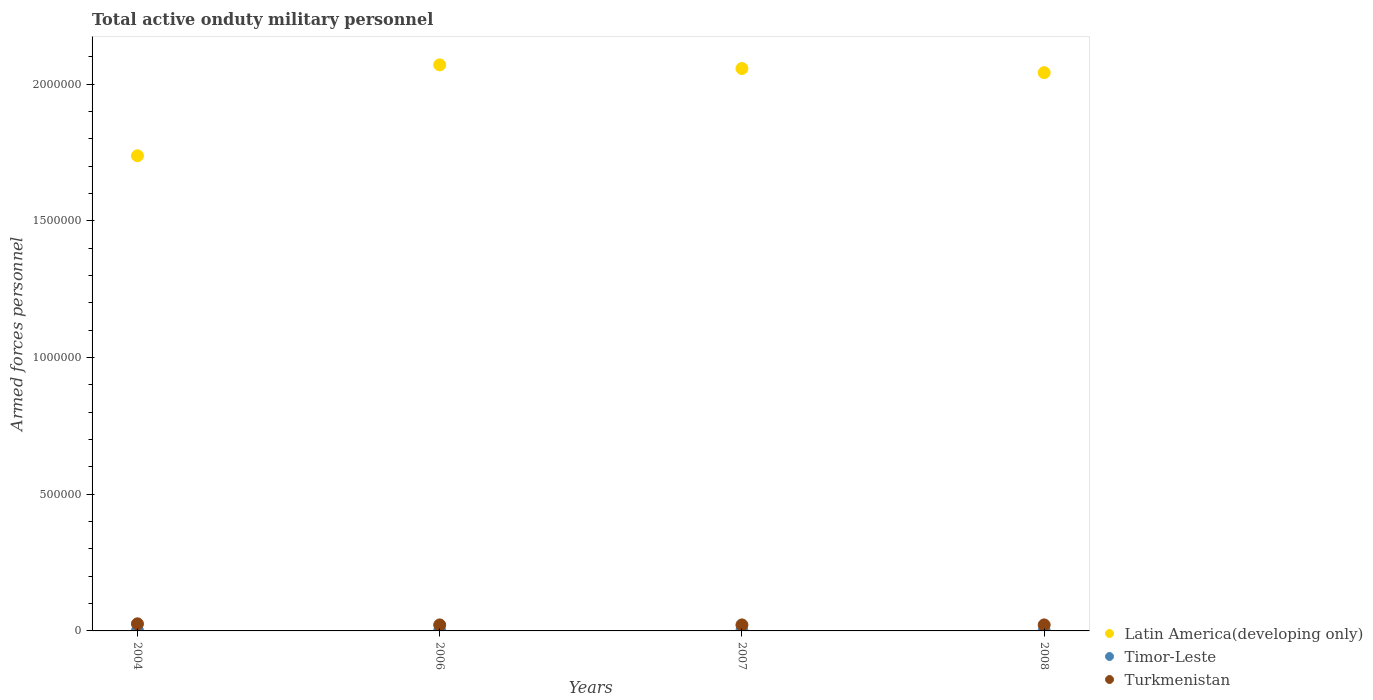What is the number of armed forces personnel in Latin America(developing only) in 2004?
Keep it short and to the point. 1.74e+06. Across all years, what is the minimum number of armed forces personnel in Turkmenistan?
Give a very brief answer. 2.20e+04. In which year was the number of armed forces personnel in Timor-Leste minimum?
Offer a terse response. 2004. What is the total number of armed forces personnel in Turkmenistan in the graph?
Make the answer very short. 9.20e+04. What is the difference between the number of armed forces personnel in Timor-Leste in 2006 and that in 2008?
Provide a succinct answer. 0. What is the difference between the number of armed forces personnel in Turkmenistan in 2006 and the number of armed forces personnel in Timor-Leste in 2007?
Your answer should be very brief. 2.10e+04. What is the average number of armed forces personnel in Turkmenistan per year?
Make the answer very short. 2.30e+04. In the year 2006, what is the difference between the number of armed forces personnel in Timor-Leste and number of armed forces personnel in Latin America(developing only)?
Offer a very short reply. -2.07e+06. In how many years, is the number of armed forces personnel in Latin America(developing only) greater than 800000?
Your answer should be very brief. 4. What is the ratio of the number of armed forces personnel in Latin America(developing only) in 2004 to that in 2007?
Provide a short and direct response. 0.84. Is the number of armed forces personnel in Timor-Leste in 2004 less than that in 2006?
Keep it short and to the point. No. Is the difference between the number of armed forces personnel in Timor-Leste in 2007 and 2008 greater than the difference between the number of armed forces personnel in Latin America(developing only) in 2007 and 2008?
Give a very brief answer. No. What is the difference between the highest and the second highest number of armed forces personnel in Timor-Leste?
Ensure brevity in your answer.  0. What is the difference between the highest and the lowest number of armed forces personnel in Latin America(developing only)?
Your response must be concise. 3.33e+05. Is the sum of the number of armed forces personnel in Turkmenistan in 2004 and 2006 greater than the maximum number of armed forces personnel in Timor-Leste across all years?
Offer a terse response. Yes. Does the number of armed forces personnel in Turkmenistan monotonically increase over the years?
Offer a very short reply. No. Is the number of armed forces personnel in Latin America(developing only) strictly greater than the number of armed forces personnel in Turkmenistan over the years?
Make the answer very short. Yes. Is the number of armed forces personnel in Turkmenistan strictly less than the number of armed forces personnel in Latin America(developing only) over the years?
Ensure brevity in your answer.  Yes. How many dotlines are there?
Your response must be concise. 3. How many years are there in the graph?
Keep it short and to the point. 4. Are the values on the major ticks of Y-axis written in scientific E-notation?
Your answer should be very brief. No. Does the graph contain any zero values?
Make the answer very short. No. Does the graph contain grids?
Your response must be concise. No. How are the legend labels stacked?
Provide a short and direct response. Vertical. What is the title of the graph?
Make the answer very short. Total active onduty military personnel. What is the label or title of the X-axis?
Keep it short and to the point. Years. What is the label or title of the Y-axis?
Your answer should be very brief. Armed forces personnel. What is the Armed forces personnel of Latin America(developing only) in 2004?
Provide a short and direct response. 1.74e+06. What is the Armed forces personnel of Turkmenistan in 2004?
Give a very brief answer. 2.60e+04. What is the Armed forces personnel in Latin America(developing only) in 2006?
Make the answer very short. 2.07e+06. What is the Armed forces personnel of Timor-Leste in 2006?
Make the answer very short. 1000. What is the Armed forces personnel in Turkmenistan in 2006?
Offer a terse response. 2.20e+04. What is the Armed forces personnel in Latin America(developing only) in 2007?
Provide a short and direct response. 2.06e+06. What is the Armed forces personnel of Turkmenistan in 2007?
Give a very brief answer. 2.20e+04. What is the Armed forces personnel in Latin America(developing only) in 2008?
Ensure brevity in your answer.  2.04e+06. What is the Armed forces personnel in Timor-Leste in 2008?
Provide a short and direct response. 1000. What is the Armed forces personnel in Turkmenistan in 2008?
Ensure brevity in your answer.  2.20e+04. Across all years, what is the maximum Armed forces personnel in Latin America(developing only)?
Your answer should be compact. 2.07e+06. Across all years, what is the maximum Armed forces personnel in Turkmenistan?
Your response must be concise. 2.60e+04. Across all years, what is the minimum Armed forces personnel in Latin America(developing only)?
Your answer should be compact. 1.74e+06. Across all years, what is the minimum Armed forces personnel in Timor-Leste?
Ensure brevity in your answer.  1000. Across all years, what is the minimum Armed forces personnel of Turkmenistan?
Keep it short and to the point. 2.20e+04. What is the total Armed forces personnel in Latin America(developing only) in the graph?
Provide a succinct answer. 7.91e+06. What is the total Armed forces personnel of Timor-Leste in the graph?
Keep it short and to the point. 4000. What is the total Armed forces personnel of Turkmenistan in the graph?
Keep it short and to the point. 9.20e+04. What is the difference between the Armed forces personnel of Latin America(developing only) in 2004 and that in 2006?
Offer a very short reply. -3.33e+05. What is the difference between the Armed forces personnel of Turkmenistan in 2004 and that in 2006?
Provide a short and direct response. 4000. What is the difference between the Armed forces personnel of Latin America(developing only) in 2004 and that in 2007?
Give a very brief answer. -3.19e+05. What is the difference between the Armed forces personnel of Turkmenistan in 2004 and that in 2007?
Your answer should be compact. 4000. What is the difference between the Armed forces personnel of Latin America(developing only) in 2004 and that in 2008?
Your answer should be compact. -3.04e+05. What is the difference between the Armed forces personnel of Timor-Leste in 2004 and that in 2008?
Ensure brevity in your answer.  0. What is the difference between the Armed forces personnel in Turkmenistan in 2004 and that in 2008?
Provide a succinct answer. 4000. What is the difference between the Armed forces personnel in Latin America(developing only) in 2006 and that in 2007?
Your response must be concise. 1.34e+04. What is the difference between the Armed forces personnel of Timor-Leste in 2006 and that in 2007?
Your answer should be compact. 0. What is the difference between the Armed forces personnel of Latin America(developing only) in 2006 and that in 2008?
Provide a succinct answer. 2.84e+04. What is the difference between the Armed forces personnel of Timor-Leste in 2006 and that in 2008?
Your answer should be compact. 0. What is the difference between the Armed forces personnel in Latin America(developing only) in 2007 and that in 2008?
Make the answer very short. 1.50e+04. What is the difference between the Armed forces personnel in Turkmenistan in 2007 and that in 2008?
Give a very brief answer. 0. What is the difference between the Armed forces personnel in Latin America(developing only) in 2004 and the Armed forces personnel in Timor-Leste in 2006?
Provide a short and direct response. 1.74e+06. What is the difference between the Armed forces personnel of Latin America(developing only) in 2004 and the Armed forces personnel of Turkmenistan in 2006?
Give a very brief answer. 1.72e+06. What is the difference between the Armed forces personnel in Timor-Leste in 2004 and the Armed forces personnel in Turkmenistan in 2006?
Provide a short and direct response. -2.10e+04. What is the difference between the Armed forces personnel of Latin America(developing only) in 2004 and the Armed forces personnel of Timor-Leste in 2007?
Keep it short and to the point. 1.74e+06. What is the difference between the Armed forces personnel in Latin America(developing only) in 2004 and the Armed forces personnel in Turkmenistan in 2007?
Your response must be concise. 1.72e+06. What is the difference between the Armed forces personnel in Timor-Leste in 2004 and the Armed forces personnel in Turkmenistan in 2007?
Keep it short and to the point. -2.10e+04. What is the difference between the Armed forces personnel of Latin America(developing only) in 2004 and the Armed forces personnel of Timor-Leste in 2008?
Provide a succinct answer. 1.74e+06. What is the difference between the Armed forces personnel in Latin America(developing only) in 2004 and the Armed forces personnel in Turkmenistan in 2008?
Provide a short and direct response. 1.72e+06. What is the difference between the Armed forces personnel of Timor-Leste in 2004 and the Armed forces personnel of Turkmenistan in 2008?
Provide a succinct answer. -2.10e+04. What is the difference between the Armed forces personnel in Latin America(developing only) in 2006 and the Armed forces personnel in Timor-Leste in 2007?
Ensure brevity in your answer.  2.07e+06. What is the difference between the Armed forces personnel in Latin America(developing only) in 2006 and the Armed forces personnel in Turkmenistan in 2007?
Provide a short and direct response. 2.05e+06. What is the difference between the Armed forces personnel of Timor-Leste in 2006 and the Armed forces personnel of Turkmenistan in 2007?
Ensure brevity in your answer.  -2.10e+04. What is the difference between the Armed forces personnel in Latin America(developing only) in 2006 and the Armed forces personnel in Timor-Leste in 2008?
Give a very brief answer. 2.07e+06. What is the difference between the Armed forces personnel of Latin America(developing only) in 2006 and the Armed forces personnel of Turkmenistan in 2008?
Ensure brevity in your answer.  2.05e+06. What is the difference between the Armed forces personnel in Timor-Leste in 2006 and the Armed forces personnel in Turkmenistan in 2008?
Give a very brief answer. -2.10e+04. What is the difference between the Armed forces personnel of Latin America(developing only) in 2007 and the Armed forces personnel of Timor-Leste in 2008?
Provide a succinct answer. 2.06e+06. What is the difference between the Armed forces personnel of Latin America(developing only) in 2007 and the Armed forces personnel of Turkmenistan in 2008?
Offer a terse response. 2.04e+06. What is the difference between the Armed forces personnel of Timor-Leste in 2007 and the Armed forces personnel of Turkmenistan in 2008?
Your answer should be very brief. -2.10e+04. What is the average Armed forces personnel of Latin America(developing only) per year?
Offer a very short reply. 1.98e+06. What is the average Armed forces personnel of Timor-Leste per year?
Provide a succinct answer. 1000. What is the average Armed forces personnel in Turkmenistan per year?
Ensure brevity in your answer.  2.30e+04. In the year 2004, what is the difference between the Armed forces personnel of Latin America(developing only) and Armed forces personnel of Timor-Leste?
Keep it short and to the point. 1.74e+06. In the year 2004, what is the difference between the Armed forces personnel in Latin America(developing only) and Armed forces personnel in Turkmenistan?
Offer a terse response. 1.71e+06. In the year 2004, what is the difference between the Armed forces personnel of Timor-Leste and Armed forces personnel of Turkmenistan?
Ensure brevity in your answer.  -2.50e+04. In the year 2006, what is the difference between the Armed forces personnel in Latin America(developing only) and Armed forces personnel in Timor-Leste?
Give a very brief answer. 2.07e+06. In the year 2006, what is the difference between the Armed forces personnel in Latin America(developing only) and Armed forces personnel in Turkmenistan?
Make the answer very short. 2.05e+06. In the year 2006, what is the difference between the Armed forces personnel in Timor-Leste and Armed forces personnel in Turkmenistan?
Offer a terse response. -2.10e+04. In the year 2007, what is the difference between the Armed forces personnel of Latin America(developing only) and Armed forces personnel of Timor-Leste?
Keep it short and to the point. 2.06e+06. In the year 2007, what is the difference between the Armed forces personnel in Latin America(developing only) and Armed forces personnel in Turkmenistan?
Give a very brief answer. 2.04e+06. In the year 2007, what is the difference between the Armed forces personnel of Timor-Leste and Armed forces personnel of Turkmenistan?
Give a very brief answer. -2.10e+04. In the year 2008, what is the difference between the Armed forces personnel in Latin America(developing only) and Armed forces personnel in Timor-Leste?
Keep it short and to the point. 2.04e+06. In the year 2008, what is the difference between the Armed forces personnel of Latin America(developing only) and Armed forces personnel of Turkmenistan?
Your answer should be very brief. 2.02e+06. In the year 2008, what is the difference between the Armed forces personnel of Timor-Leste and Armed forces personnel of Turkmenistan?
Ensure brevity in your answer.  -2.10e+04. What is the ratio of the Armed forces personnel in Latin America(developing only) in 2004 to that in 2006?
Provide a short and direct response. 0.84. What is the ratio of the Armed forces personnel in Turkmenistan in 2004 to that in 2006?
Ensure brevity in your answer.  1.18. What is the ratio of the Armed forces personnel in Latin America(developing only) in 2004 to that in 2007?
Ensure brevity in your answer.  0.84. What is the ratio of the Armed forces personnel of Timor-Leste in 2004 to that in 2007?
Offer a very short reply. 1. What is the ratio of the Armed forces personnel in Turkmenistan in 2004 to that in 2007?
Provide a succinct answer. 1.18. What is the ratio of the Armed forces personnel of Latin America(developing only) in 2004 to that in 2008?
Your answer should be very brief. 0.85. What is the ratio of the Armed forces personnel in Timor-Leste in 2004 to that in 2008?
Make the answer very short. 1. What is the ratio of the Armed forces personnel of Turkmenistan in 2004 to that in 2008?
Your answer should be compact. 1.18. What is the ratio of the Armed forces personnel of Latin America(developing only) in 2006 to that in 2007?
Give a very brief answer. 1.01. What is the ratio of the Armed forces personnel of Latin America(developing only) in 2006 to that in 2008?
Give a very brief answer. 1.01. What is the ratio of the Armed forces personnel of Turkmenistan in 2006 to that in 2008?
Provide a short and direct response. 1. What is the ratio of the Armed forces personnel of Latin America(developing only) in 2007 to that in 2008?
Your answer should be compact. 1.01. What is the ratio of the Armed forces personnel in Timor-Leste in 2007 to that in 2008?
Offer a terse response. 1. What is the difference between the highest and the second highest Armed forces personnel in Latin America(developing only)?
Provide a succinct answer. 1.34e+04. What is the difference between the highest and the second highest Armed forces personnel of Timor-Leste?
Keep it short and to the point. 0. What is the difference between the highest and the second highest Armed forces personnel of Turkmenistan?
Ensure brevity in your answer.  4000. What is the difference between the highest and the lowest Armed forces personnel in Latin America(developing only)?
Provide a succinct answer. 3.33e+05. What is the difference between the highest and the lowest Armed forces personnel of Timor-Leste?
Provide a succinct answer. 0. What is the difference between the highest and the lowest Armed forces personnel of Turkmenistan?
Offer a terse response. 4000. 